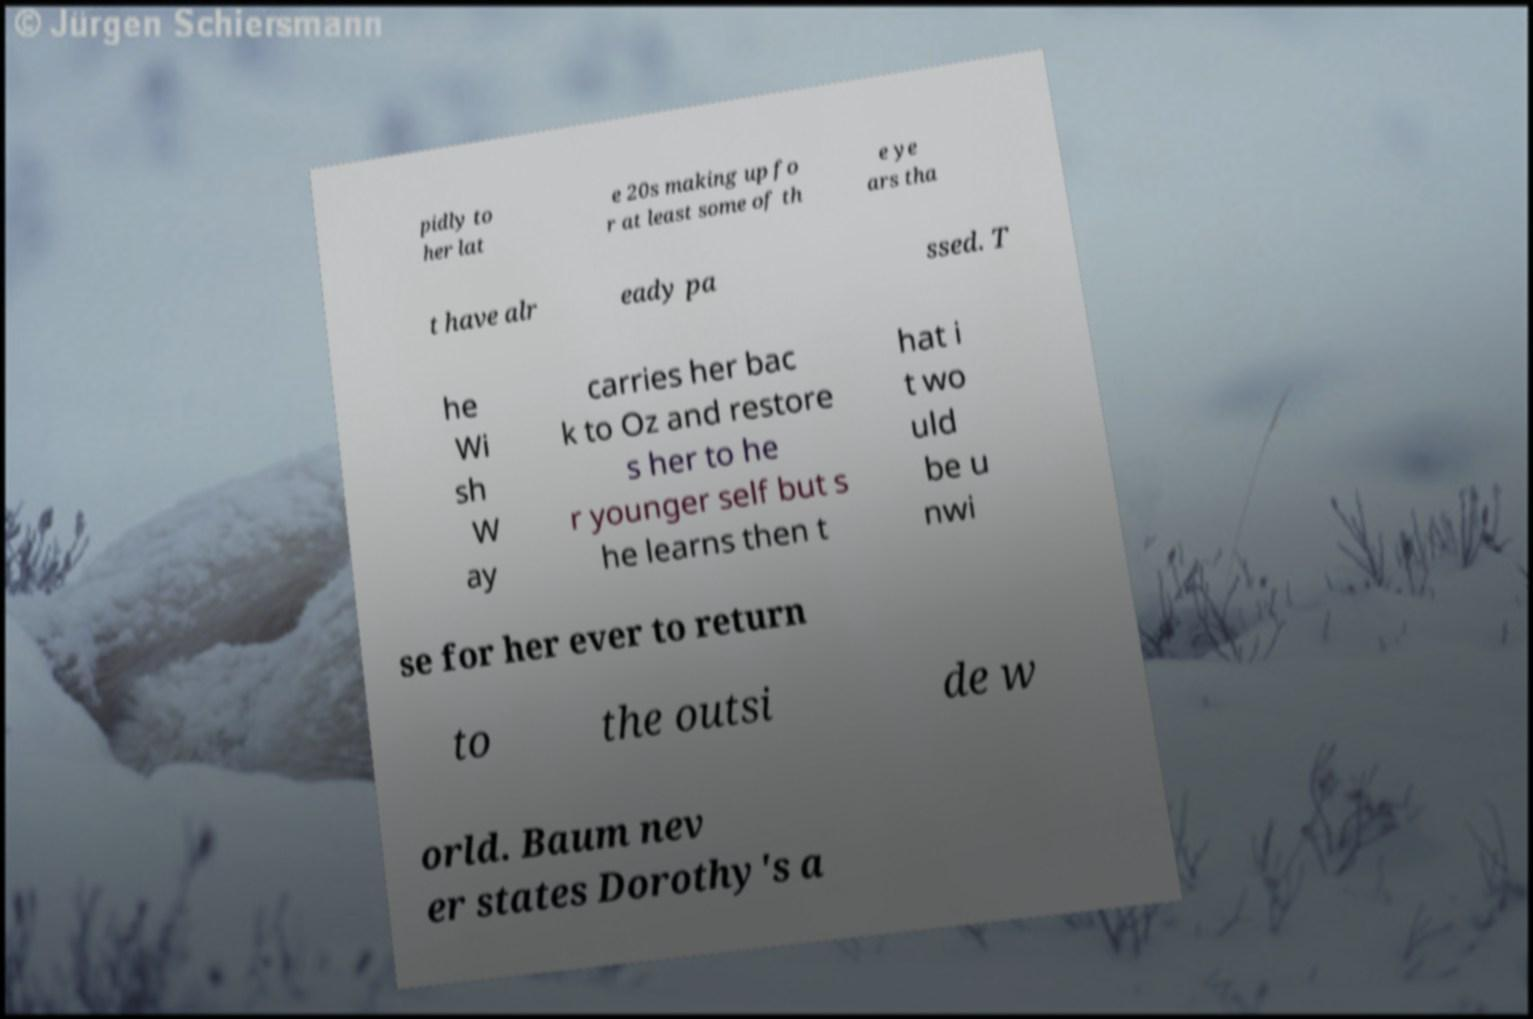Please read and relay the text visible in this image. What does it say? pidly to her lat e 20s making up fo r at least some of th e ye ars tha t have alr eady pa ssed. T he Wi sh W ay carries her bac k to Oz and restore s her to he r younger self but s he learns then t hat i t wo uld be u nwi se for her ever to return to the outsi de w orld. Baum nev er states Dorothy's a 